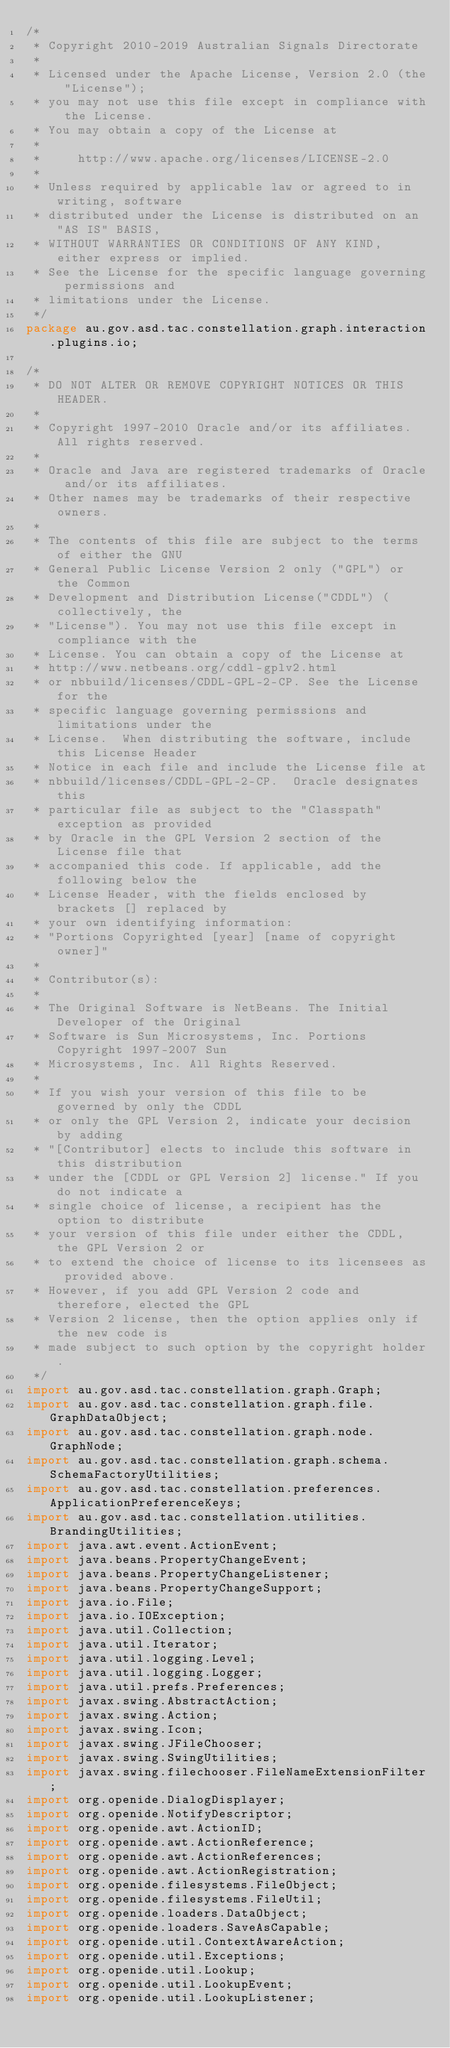Convert code to text. <code><loc_0><loc_0><loc_500><loc_500><_Java_>/*
 * Copyright 2010-2019 Australian Signals Directorate
 *
 * Licensed under the Apache License, Version 2.0 (the "License");
 * you may not use this file except in compliance with the License.
 * You may obtain a copy of the License at
 *
 *     http://www.apache.org/licenses/LICENSE-2.0
 *
 * Unless required by applicable law or agreed to in writing, software
 * distributed under the License is distributed on an "AS IS" BASIS,
 * WITHOUT WARRANTIES OR CONDITIONS OF ANY KIND, either express or implied.
 * See the License for the specific language governing permissions and
 * limitations under the License.
 */
package au.gov.asd.tac.constellation.graph.interaction.plugins.io;

/*
 * DO NOT ALTER OR REMOVE COPYRIGHT NOTICES OR THIS HEADER.
 *
 * Copyright 1997-2010 Oracle and/or its affiliates. All rights reserved.
 *
 * Oracle and Java are registered trademarks of Oracle and/or its affiliates.
 * Other names may be trademarks of their respective owners.
 *
 * The contents of this file are subject to the terms of either the GNU
 * General Public License Version 2 only ("GPL") or the Common
 * Development and Distribution License("CDDL") (collectively, the
 * "License"). You may not use this file except in compliance with the
 * License. You can obtain a copy of the License at
 * http://www.netbeans.org/cddl-gplv2.html
 * or nbbuild/licenses/CDDL-GPL-2-CP. See the License for the
 * specific language governing permissions and limitations under the
 * License.  When distributing the software, include this License Header
 * Notice in each file and include the License file at
 * nbbuild/licenses/CDDL-GPL-2-CP.  Oracle designates this
 * particular file as subject to the "Classpath" exception as provided
 * by Oracle in the GPL Version 2 section of the License file that
 * accompanied this code. If applicable, add the following below the
 * License Header, with the fields enclosed by brackets [] replaced by
 * your own identifying information:
 * "Portions Copyrighted [year] [name of copyright owner]"
 *
 * Contributor(s):
 *
 * The Original Software is NetBeans. The Initial Developer of the Original
 * Software is Sun Microsystems, Inc. Portions Copyright 1997-2007 Sun
 * Microsystems, Inc. All Rights Reserved.
 *
 * If you wish your version of this file to be governed by only the CDDL
 * or only the GPL Version 2, indicate your decision by adding
 * "[Contributor] elects to include this software in this distribution
 * under the [CDDL or GPL Version 2] license." If you do not indicate a
 * single choice of license, a recipient has the option to distribute
 * your version of this file under either the CDDL, the GPL Version 2 or
 * to extend the choice of license to its licensees as provided above.
 * However, if you add GPL Version 2 code and therefore, elected the GPL
 * Version 2 license, then the option applies only if the new code is
 * made subject to such option by the copyright holder.
 */
import au.gov.asd.tac.constellation.graph.Graph;
import au.gov.asd.tac.constellation.graph.file.GraphDataObject;
import au.gov.asd.tac.constellation.graph.node.GraphNode;
import au.gov.asd.tac.constellation.graph.schema.SchemaFactoryUtilities;
import au.gov.asd.tac.constellation.preferences.ApplicationPreferenceKeys;
import au.gov.asd.tac.constellation.utilities.BrandingUtilities;
import java.awt.event.ActionEvent;
import java.beans.PropertyChangeEvent;
import java.beans.PropertyChangeListener;
import java.beans.PropertyChangeSupport;
import java.io.File;
import java.io.IOException;
import java.util.Collection;
import java.util.Iterator;
import java.util.logging.Level;
import java.util.logging.Logger;
import java.util.prefs.Preferences;
import javax.swing.AbstractAction;
import javax.swing.Action;
import javax.swing.Icon;
import javax.swing.JFileChooser;
import javax.swing.SwingUtilities;
import javax.swing.filechooser.FileNameExtensionFilter;
import org.openide.DialogDisplayer;
import org.openide.NotifyDescriptor;
import org.openide.awt.ActionID;
import org.openide.awt.ActionReference;
import org.openide.awt.ActionReferences;
import org.openide.awt.ActionRegistration;
import org.openide.filesystems.FileObject;
import org.openide.filesystems.FileUtil;
import org.openide.loaders.DataObject;
import org.openide.loaders.SaveAsCapable;
import org.openide.util.ContextAwareAction;
import org.openide.util.Exceptions;
import org.openide.util.Lookup;
import org.openide.util.LookupEvent;
import org.openide.util.LookupListener;</code> 